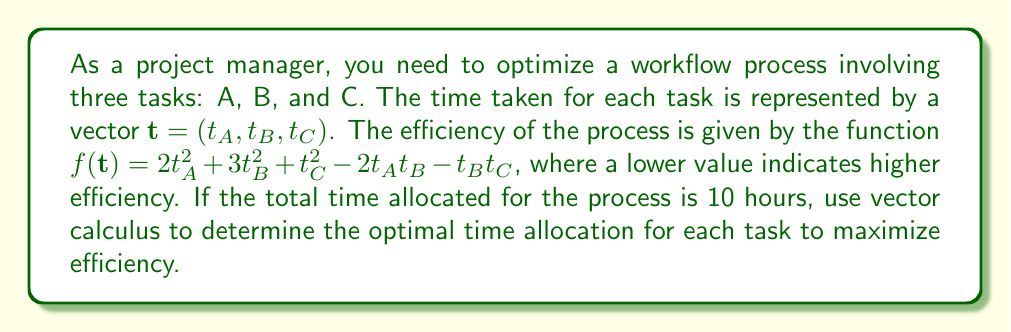Can you answer this question? To solve this optimization problem, we'll use the method of Lagrange multipliers:

1) First, we set up the constraint equation:
   $g(\mathbf{t}) = t_A + t_B + t_C - 10 = 0$

2) We form the Lagrangian function:
   $L(\mathbf{t}, \lambda) = f(\mathbf{t}) - \lambda g(\mathbf{t})$
   $L(\mathbf{t}, \lambda) = 2t_A^2 + 3t_B^2 + t_C^2 - 2t_At_B - t_Bt_C - \lambda(t_A + t_B + t_C - 10)$

3) We calculate the partial derivatives and set them to zero:
   $\frac{\partial L}{\partial t_A} = 4t_A - 2t_B - \lambda = 0$
   $\frac{\partial L}{\partial t_B} = 6t_B - 2t_A - t_C - \lambda = 0$
   $\frac{\partial L}{\partial t_C} = 2t_C - t_B - \lambda = 0$
   $\frac{\partial L}{\partial \lambda} = t_A + t_B + t_C - 10 = 0$

4) From these equations, we can derive:
   $t_A = \frac{\lambda}{2} + \frac{t_B}{2}$
   $t_C = \frac{\lambda}{2} + \frac{t_B}{2}$

5) Substituting these into the second equation:
   $6t_B - 2(\frac{\lambda}{2} + \frac{t_B}{2}) - (\frac{\lambda}{2} + \frac{t_B}{2}) - \lambda = 0$
   $6t_B - \lambda - t_B - \frac{\lambda}{2} - \frac{t_B}{2} - \lambda = 0$
   $\frac{9t_B}{2} - \frac{5\lambda}{2} = 0$
   $t_B = \frac{5\lambda}{9}$

6) Substituting all of these into the constraint equation:
   $(\frac{\lambda}{2} + \frac{5\lambda}{18}) + \frac{5\lambda}{9} + (\frac{\lambda}{2} + \frac{5\lambda}{18}) = 10$
   $\frac{9\lambda + 5\lambda + 10\lambda + 9\lambda + 5\lambda}{18} = 10$
   $\frac{38\lambda}{18} = 10$
   $\lambda = \frac{180}{38} = \frac{90}{19}$

7) Now we can calculate $t_A$, $t_B$, and $t_C$:
   $t_B = \frac{5\lambda}{9} = \frac{5}{9} \cdot \frac{90}{19} = \frac{50}{19}$
   $t_A = t_C = \frac{\lambda}{2} + \frac{t_B}{2} = \frac{45}{19} + \frac{25}{19} = \frac{70}{19}$

Therefore, the optimal time allocation is:
$t_A = t_C = \frac{70}{19}$ hours, and $t_B = \frac{50}{19}$ hours.
Answer: $t_A = t_C \approx 3.68$ hours, $t_B \approx 2.63$ hours 